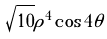Convert formula to latex. <formula><loc_0><loc_0><loc_500><loc_500>\sqrt { 1 0 } \rho ^ { 4 } \cos 4 \theta</formula> 